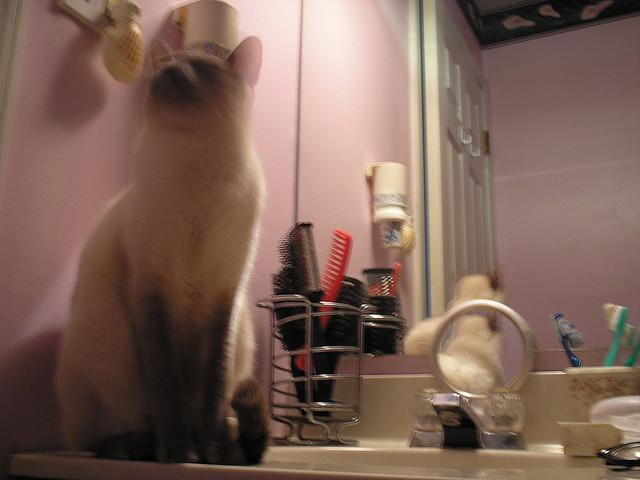What kind of cat is this?
Quick response, please. Siamese. How many toothbrush do you see?
Quick response, please. 2. What color is the paint on the wall?
Give a very brief answer. Pink. 